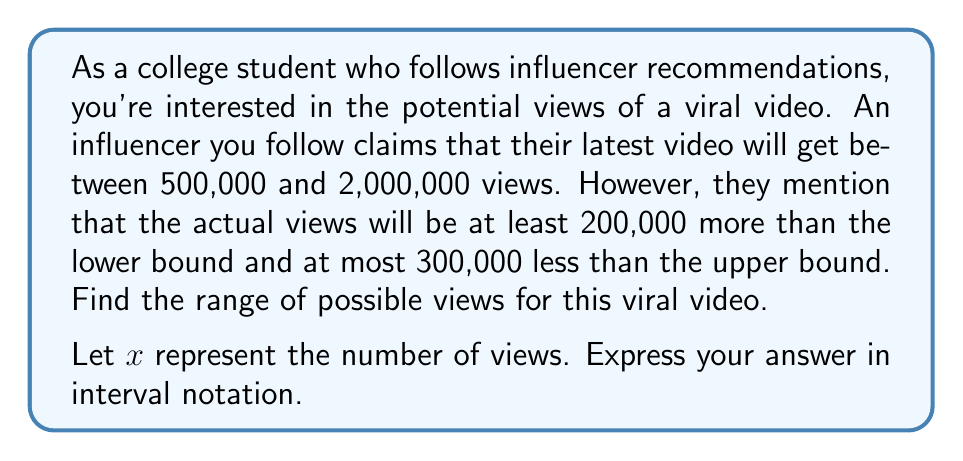Give your solution to this math problem. Let's approach this step-by-step:

1) First, let's establish the initial bounds:
   Lower bound: 500,000
   Upper bound: 2,000,000

2) Now, we need to adjust these bounds based on the additional information:
   - The actual views will be at least 200,000 more than the lower bound
   - The actual views will be at most 300,000 less than the upper bound

3) Let's adjust the lower bound:
   New lower bound = 500,000 + 200,000 = 700,000

4) Let's adjust the upper bound:
   New upper bound = 2,000,000 - 300,000 = 1,700,000

5) Now we can express this as an inequality:
   $700,000 \leq x \leq 1,700,000$

6) In interval notation, this is written as $[700000, 1700000]$

Therefore, the range of possible views for this viral video is $[700000, 1700000]$.
Answer: $[700000, 1700000]$ 